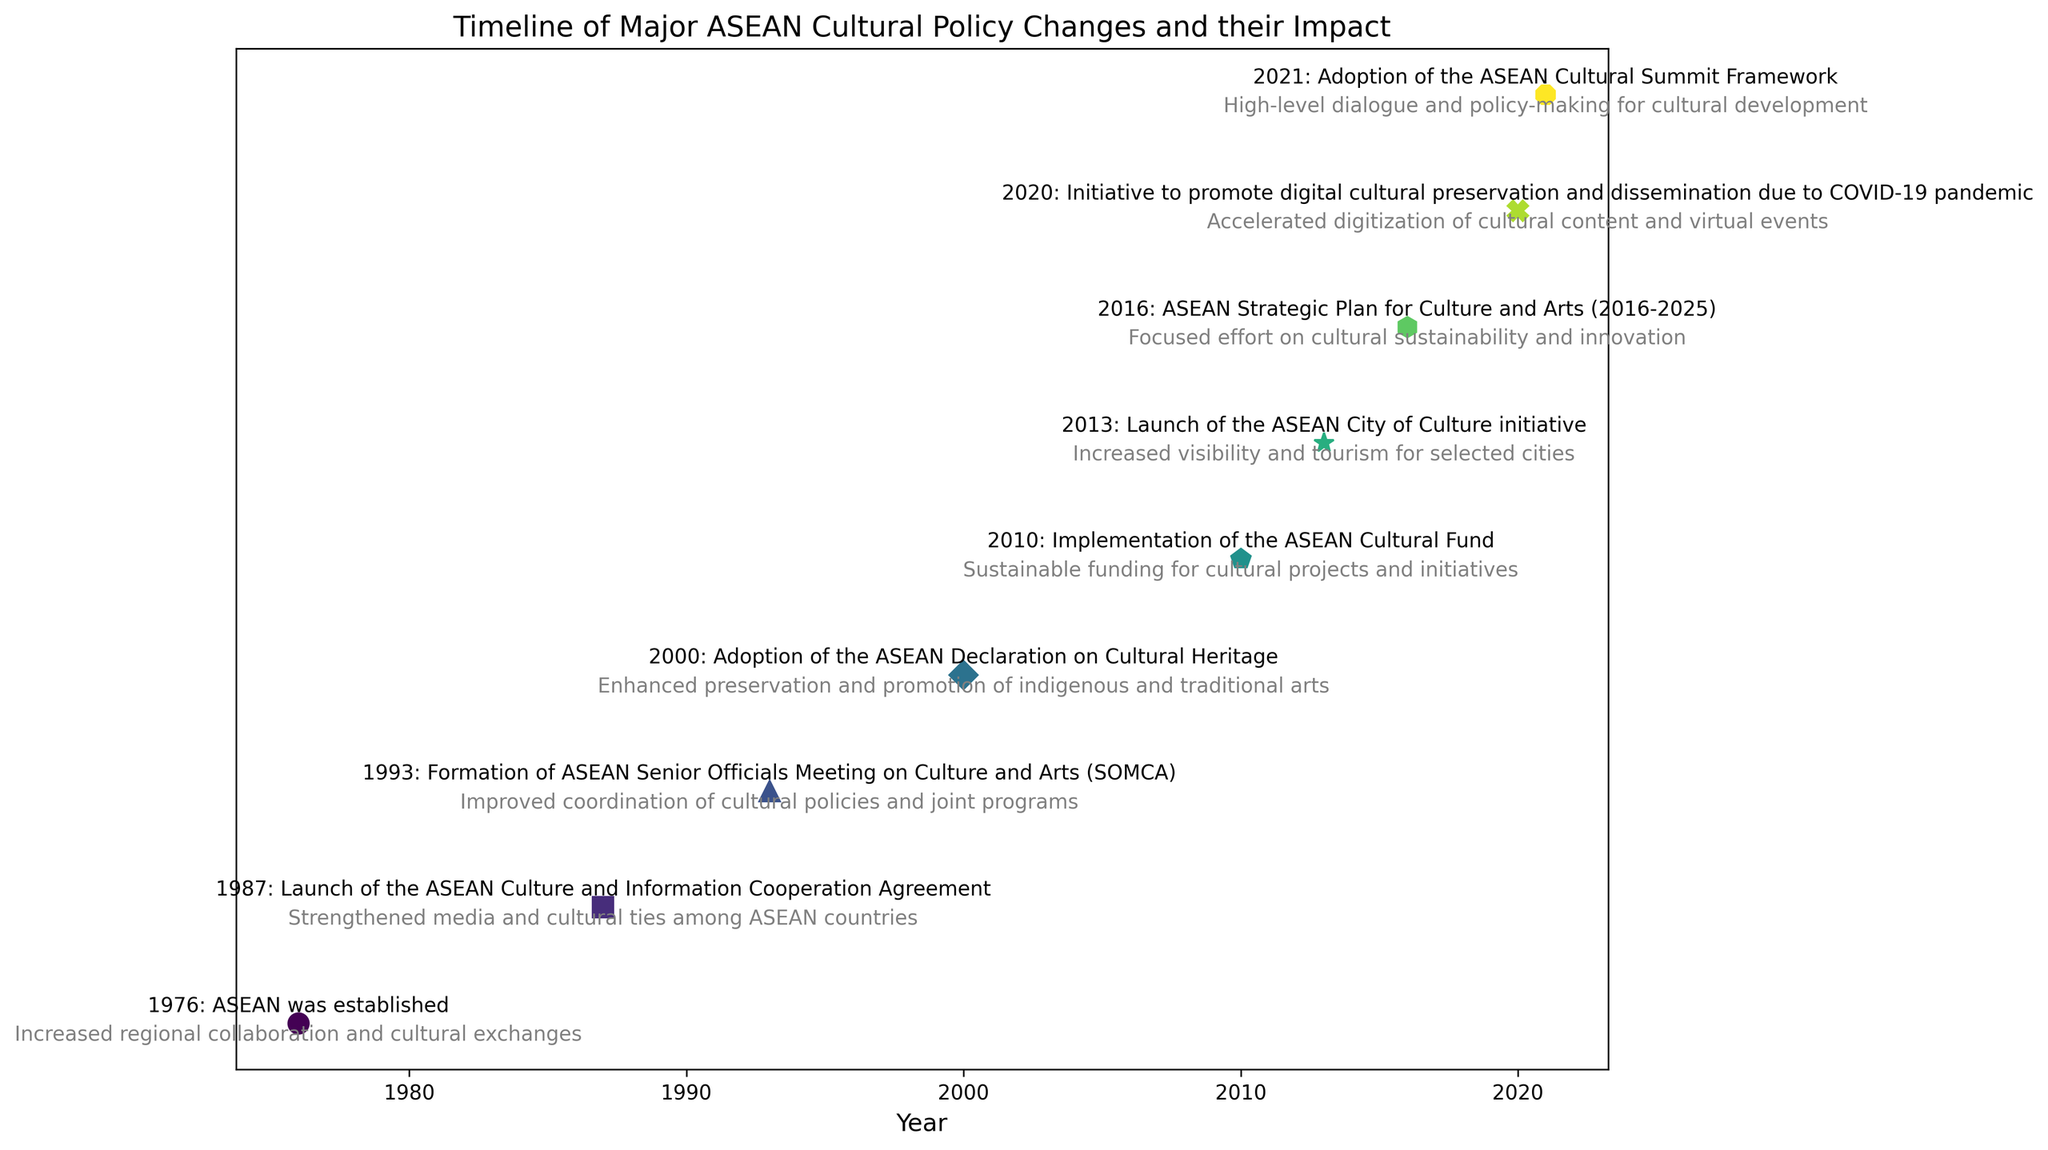What was the earliest policy change on the timeline? Look to the start of the timeline. The earliest date noted is 1976. The policy change for that year is "ASEAN was established."
Answer: ASEAN was established Which policy change in the timeline provided sustainable funding for cultural projects and initiatives? Referring to the various policy changes listed on the timeline, the policy change in 2010 is marked as "Implementation of the ASEAN Cultural Fund," which provided sustainable funding for cultural projects and initiatives.
Answer: Implementation of the ASEAN Cultural Fund How many years after the launch of the ASEAN City of Culture initiative was the ASEAN Strategic Plan for Culture and Arts (2016-2025) introduced? The ASEAN City of Culture initiative was launched in 2013. The ASEAN Strategic Plan for Culture and Arts was introduced in 2016. By subtracting the earlier year from the later year: 2016 - 2013 = 3 years.
Answer: 3 years What policy change led to the accelerated digitization of cultural content and virtual events? On the timeline, look for the policy change related to digitization. In 2020, the policy change was "Initiative to promote digital cultural preservation and dissemination due to COVID-19 pandemic." Hence, this initiative led to the accelerated digitization of cultural content and virtual events.
Answer: Initiative to promote digital cultural preservation and dissemination due to COVID-19 pandemic Compare the impacts of the ASEAN Culture and Information Cooperation Agreement and the ASEAN Declaration on Cultural Heritage on local arts organizations. Which had a more direct influence on preservation and promotion of indigenous and traditional arts? The ASEAN Culture and Information Cooperation Agreement (1987) aimed to strengthen media and cultural ties among ASEAN countries, whereas the ASEAN Declaration on Cultural Heritage (2000) enhanced preservation and promotion of indigenous and traditional arts. Based on the impacts described, the ASEAN Declaration on Cultural Heritage had a more direct influence on preservation and promotion of indigenous and traditional arts.
Answer: ASEAN Declaration on Cultural Heritage Between 1976 and 2021, how many major ASEAN cultural policy changes can be observed on the timeline? Count the number of distinct policy changes listed between the years 1976 and 2021 inclusive. There are nine such policy changes: 1976, 1987, 1993, 2000, 2010, 2013, 2016, 2020, and 2021.
Answer: 9 Assessing the visual distribution, which years had policy changes marked with circular markers? Inspect the markers used in the timeline. Circular markers are used for the years: 1976 (ASEAN was established).
Answer: 1976 What is the primary impact of the formation of the ASEAN Senior Officials Meeting on Culture and Arts (SOMCA) on local arts organizations? The Formation of the ASEAN Senior Officials Meeting on Culture and Arts (SOMCA) happened in 1993. The main impact listed for this policy change is the "Improved coordination of cultural policies and joint programs."
Answer: Improved coordination of cultural policies and joint programs 